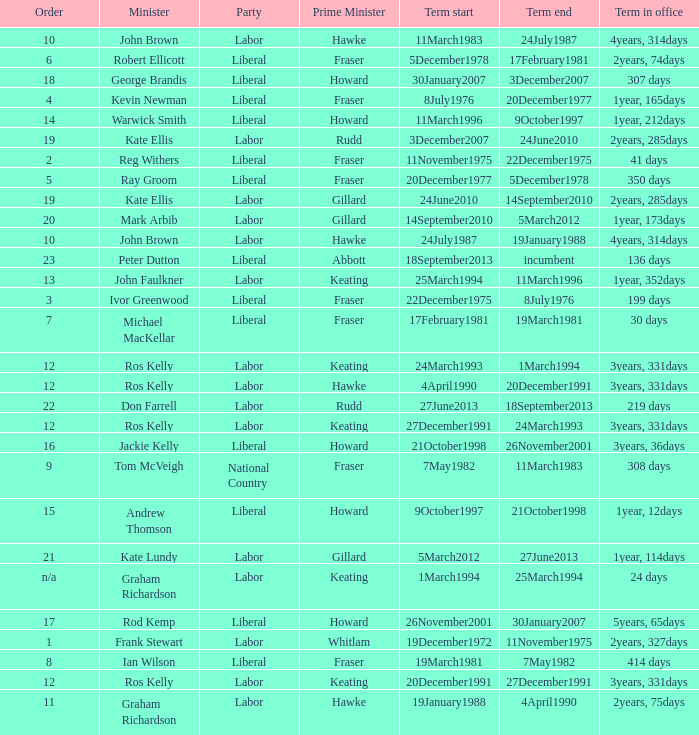What is the Term in office with an Order that is 9? 308 days. 